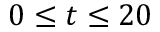<formula> <loc_0><loc_0><loc_500><loc_500>0 \leq t \leq 2 0</formula> 